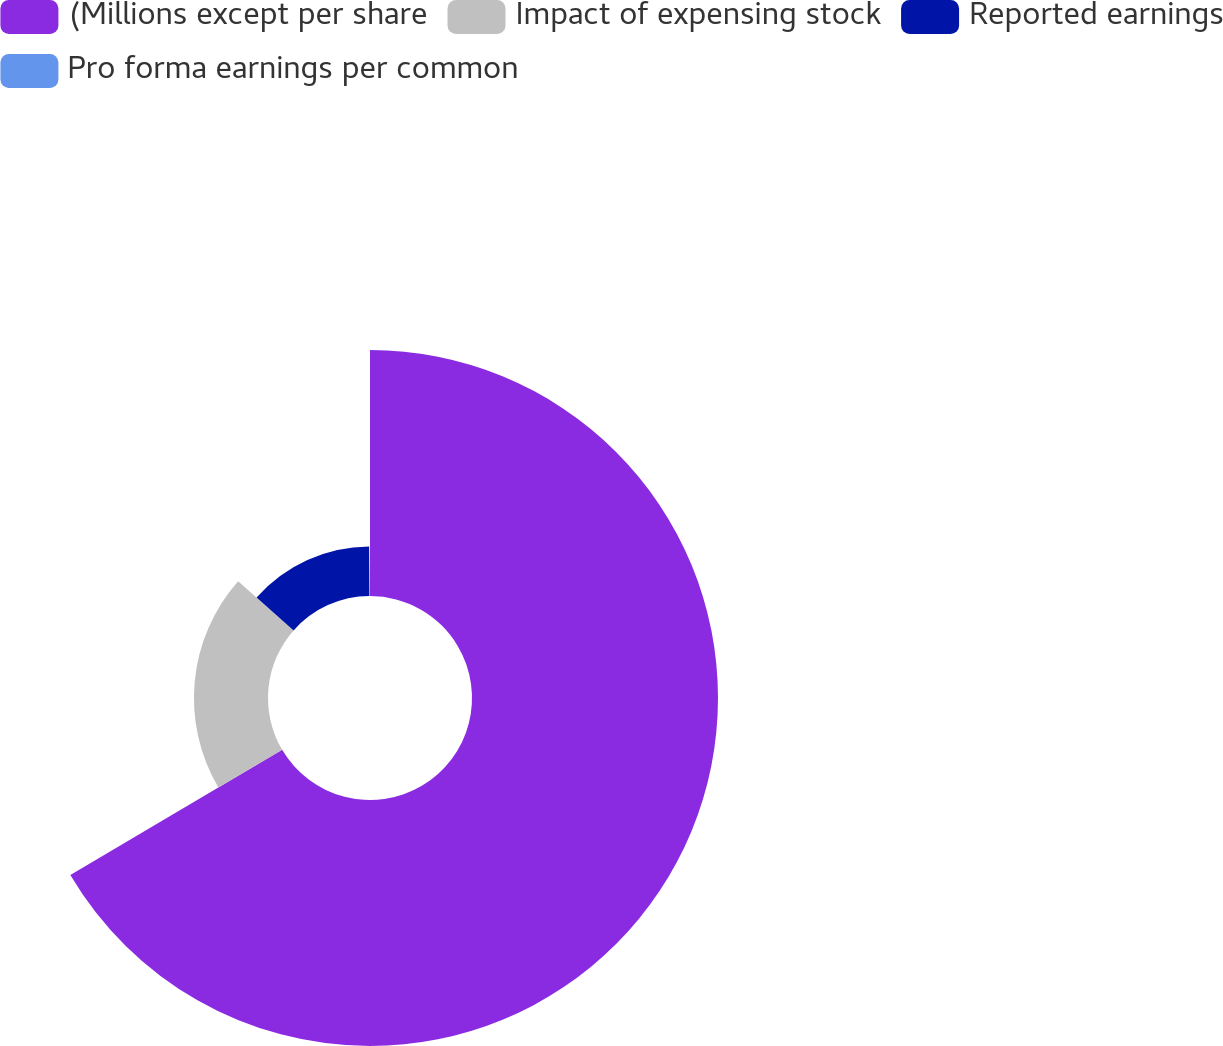<chart> <loc_0><loc_0><loc_500><loc_500><pie_chart><fcel>(Millions except per share<fcel>Impact of expensing stock<fcel>Reported earnings<fcel>Pro forma earnings per common<nl><fcel>66.51%<fcel>20.02%<fcel>13.38%<fcel>0.09%<nl></chart> 